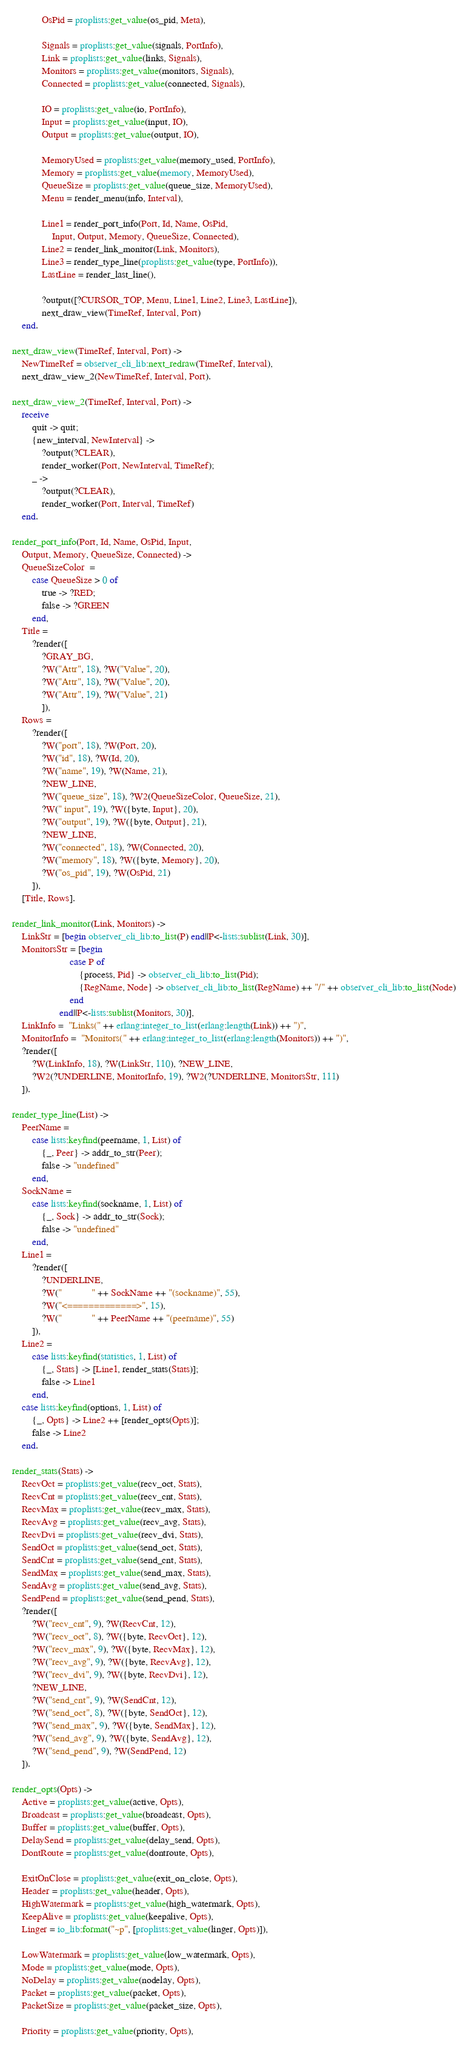<code> <loc_0><loc_0><loc_500><loc_500><_Erlang_>            OsPid = proplists:get_value(os_pid, Meta),
            
            Signals = proplists:get_value(signals, PortInfo),
            Link = proplists:get_value(links, Signals),
            Monitors = proplists:get_value(monitors, Signals),
            Connected = proplists:get_value(connected, Signals),
            
            IO = proplists:get_value(io, PortInfo),
            Input = proplists:get_value(input, IO),
            Output = proplists:get_value(output, IO),
            
            MemoryUsed = proplists:get_value(memory_used, PortInfo),
            Memory = proplists:get_value(memory, MemoryUsed),
            QueueSize = proplists:get_value(queue_size, MemoryUsed),
            Menu = render_menu(info, Interval),
            
            Line1 = render_port_info(Port, Id, Name, OsPid,
                Input, Output, Memory, QueueSize, Connected),
            Line2 = render_link_monitor(Link, Monitors),
            Line3 = render_type_line(proplists:get_value(type, PortInfo)),
            LastLine = render_last_line(),
            
            ?output([?CURSOR_TOP, Menu, Line1, Line2, Line3, LastLine]),
            next_draw_view(TimeRef, Interval, Port)
    end.

next_draw_view(TimeRef, Interval, Port) ->
    NewTimeRef = observer_cli_lib:next_redraw(TimeRef, Interval),
    next_draw_view_2(NewTimeRef, Interval, Port).

next_draw_view_2(TimeRef, Interval, Port) ->
    receive
        quit -> quit;
        {new_interval, NewInterval} ->
            ?output(?CLEAR),
            render_worker(Port, NewInterval, TimeRef);
        _ ->
            ?output(?CLEAR),
            render_worker(Port, Interval, TimeRef)
    end.

render_port_info(Port, Id, Name, OsPid, Input,
    Output, Memory, QueueSize, Connected) ->
    QueueSizeColor  =
        case QueueSize > 0 of
            true -> ?RED;
            false -> ?GREEN
        end,
    Title =
        ?render([
            ?GRAY_BG,
            ?W("Attr", 18), ?W("Value", 20),
            ?W("Attr", 18), ?W("Value", 20),
            ?W("Attr", 19), ?W("Value", 21)
            ]),
    Rows =
        ?render([
            ?W("port", 18), ?W(Port, 20),
            ?W("id", 18), ?W(Id, 20),
            ?W("name", 19), ?W(Name, 21),
            ?NEW_LINE,
            ?W("queue_size", 18), ?W2(QueueSizeColor, QueueSize, 21),
            ?W(" input", 19), ?W({byte, Input}, 20),
            ?W("output", 19), ?W({byte, Output}, 21),
            ?NEW_LINE,
            ?W("connected", 18), ?W(Connected, 20),
            ?W("memory", 18), ?W({byte, Memory}, 20),
            ?W("os_pid", 19), ?W(OsPid, 21)
        ]),
    [Title, Rows].

render_link_monitor(Link, Monitors) ->
    LinkStr = [begin observer_cli_lib:to_list(P) end||P<-lists:sublist(Link, 30)],
    MonitorsStr = [begin
                       case P of
                           {process, Pid} -> observer_cli_lib:to_list(Pid);
                           {RegName, Node} -> observer_cli_lib:to_list(RegName) ++ "/" ++ observer_cli_lib:to_list(Node)
                       end
                   end||P<-lists:sublist(Monitors, 30)],
    LinkInfo =  "Links(" ++ erlang:integer_to_list(erlang:length(Link)) ++ ")",
    MonitorInfo =  "Monitors(" ++ erlang:integer_to_list(erlang:length(Monitors)) ++ ")",
    ?render([
        ?W(LinkInfo, 18), ?W(LinkStr, 110), ?NEW_LINE,
        ?W2(?UNDERLINE, MonitorInfo, 19), ?W2(?UNDERLINE, MonitorsStr, 111)
    ]).

render_type_line(List) ->
    PeerName =
        case lists:keyfind(peername, 1, List) of
            {_, Peer} -> addr_to_str(Peer);
            false -> "undefined"
        end,
    SockName =
        case lists:keyfind(sockname, 1, List) of
            {_, Sock} -> addr_to_str(Sock);
            false -> "undefined"
        end,
    Line1 =
        ?render([
            ?UNDERLINE,
            ?W("            " ++ SockName ++ "(sockname)", 55),
            ?W("<=============>", 15),
            ?W("            " ++ PeerName ++ "(peername)", 55)
        ]),
    Line2 =
        case lists:keyfind(statistics, 1, List) of
            {_, Stats} -> [Line1, render_stats(Stats)];
            false -> Line1
        end,
    case lists:keyfind(options, 1, List) of
        {_, Opts} -> Line2 ++ [render_opts(Opts)];
        false -> Line2
    end.

render_stats(Stats) ->
    RecvOct = proplists:get_value(recv_oct, Stats),
    RecvCnt = proplists:get_value(recv_cnt, Stats),
    RecvMax = proplists:get_value(recv_max, Stats),
    RecvAvg = proplists:get_value(recv_avg, Stats),
    RecvDvi = proplists:get_value(recv_dvi, Stats),
    SendOct = proplists:get_value(send_oct, Stats),
    SendCnt = proplists:get_value(send_cnt, Stats),
    SendMax = proplists:get_value(send_max, Stats),
    SendAvg = proplists:get_value(send_avg, Stats),
    SendPend = proplists:get_value(send_pend, Stats),
    ?render([
        ?W("recv_cnt", 9), ?W(RecvCnt, 12),
        ?W("recv_oct", 8), ?W({byte, RecvOct}, 12),
        ?W("recv_max", 9), ?W({byte, RecvMax}, 12),
        ?W("recv_avg", 9), ?W({byte, RecvAvg}, 12),
        ?W("recv_dvi", 9), ?W({byte, RecvDvi}, 12),
        ?NEW_LINE,
        ?W("send_cnt", 9), ?W(SendCnt, 12),
        ?W("send_oct", 8), ?W({byte, SendOct}, 12),
        ?W("send_max", 9), ?W({byte, SendMax}, 12),
        ?W("send_avg", 9), ?W({byte, SendAvg}, 12),
        ?W("send_pend", 9), ?W(SendPend, 12)
    ]).

render_opts(Opts) ->
    Active = proplists:get_value(active, Opts),
    Broadcast = proplists:get_value(broadcast, Opts),
    Buffer = proplists:get_value(buffer, Opts),
    DelaySend = proplists:get_value(delay_send, Opts),
    DontRoute = proplists:get_value(dontroute, Opts),
    
    ExitOnClose = proplists:get_value(exit_on_close, Opts),
    Header = proplists:get_value(header, Opts),
    HighWatermark = proplists:get_value(high_watermark, Opts),
    KeepAlive = proplists:get_value(keepalive, Opts),
    Linger = io_lib:format("~p", [proplists:get_value(linger, Opts)]),
    
    LowWatermark = proplists:get_value(low_watermark, Opts),
    Mode = proplists:get_value(mode, Opts),
    NoDelay = proplists:get_value(nodelay, Opts),
    Packet = proplists:get_value(packet, Opts),
    PacketSize = proplists:get_value(packet_size, Opts),
    
    Priority = proplists:get_value(priority, Opts),</code> 